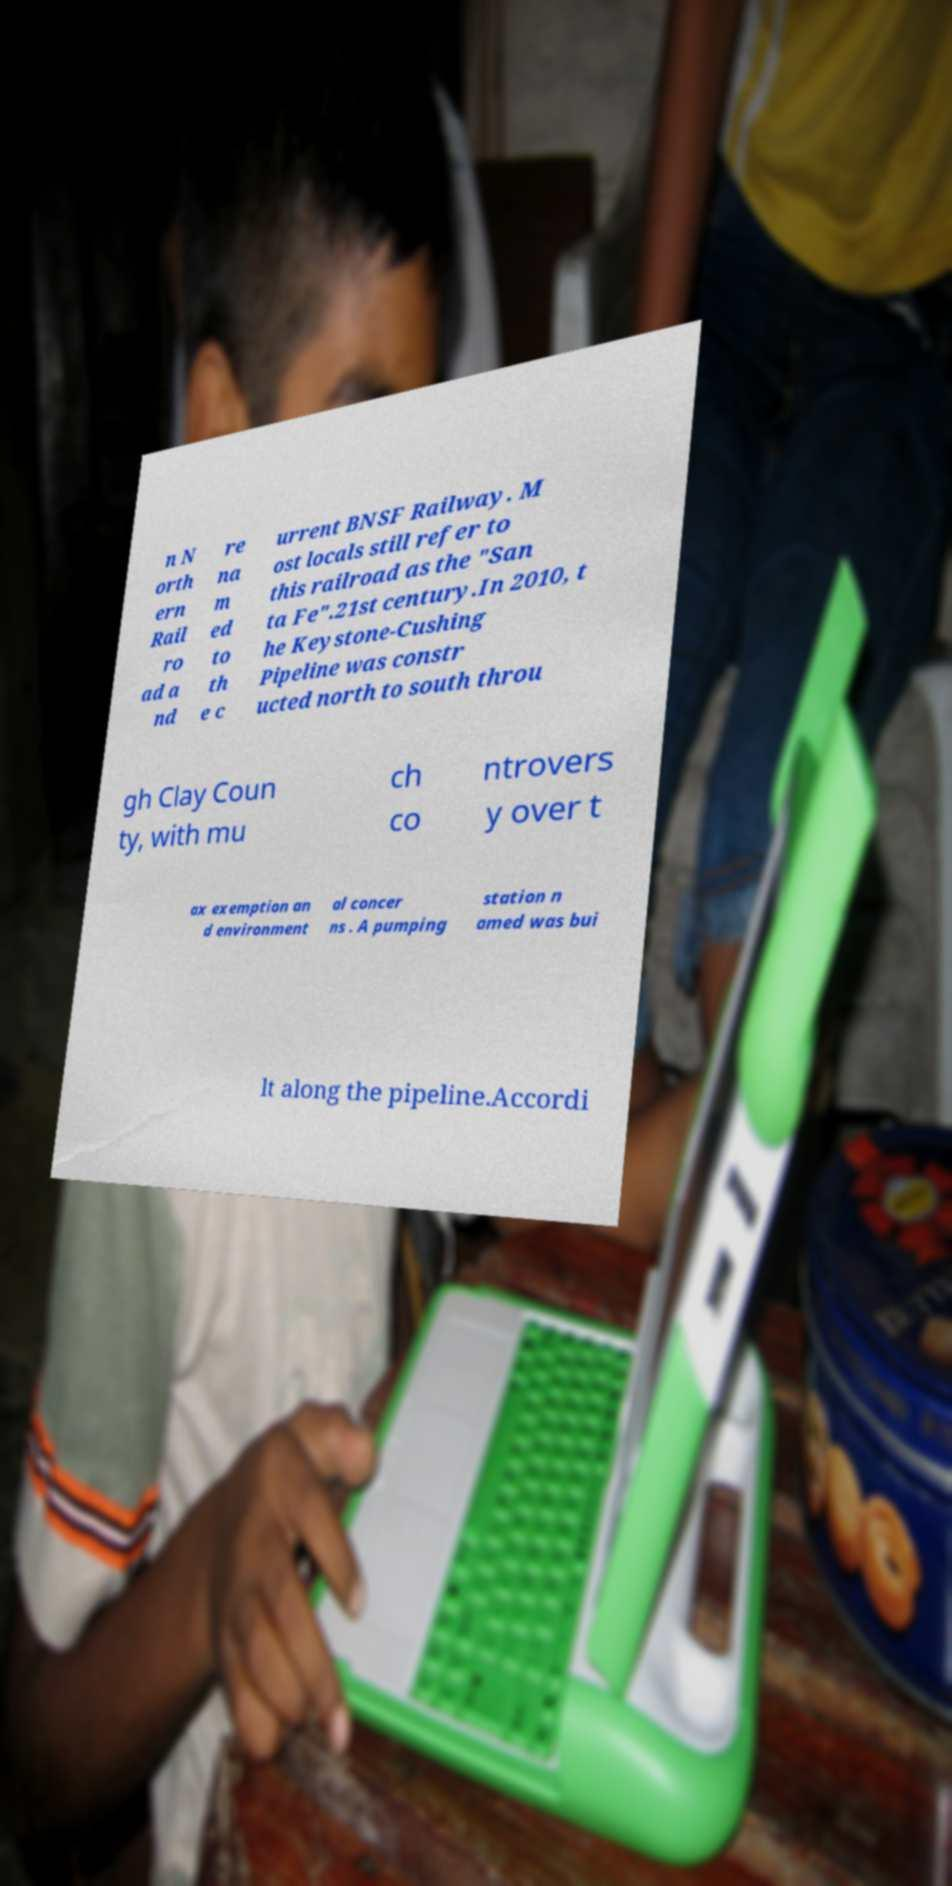What messages or text are displayed in this image? I need them in a readable, typed format. n N orth ern Rail ro ad a nd re na m ed to th e c urrent BNSF Railway. M ost locals still refer to this railroad as the "San ta Fe".21st century.In 2010, t he Keystone-Cushing Pipeline was constr ucted north to south throu gh Clay Coun ty, with mu ch co ntrovers y over t ax exemption an d environment al concer ns . A pumping station n amed was bui lt along the pipeline.Accordi 